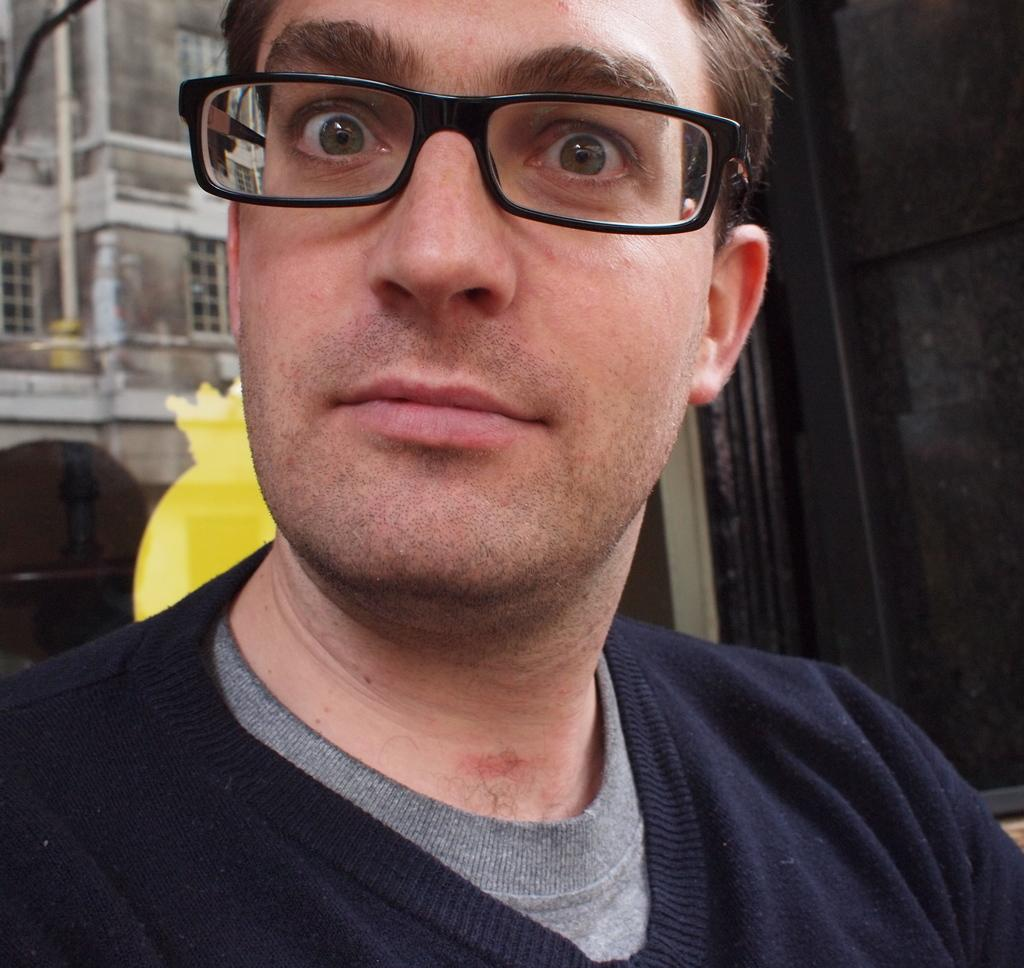Who is the main subject in the image? There is a man in the image. Where is the man positioned in the image? The man is in the front of the image. What is the man wearing? The man is wearing a black dress and specs. What can be seen in the background of the image? There is a building, windows, and a yellow color thing visible in the background. What type of battle is taking place in the image? There is no battle present in the image; it features a man in the front and a background with a building, windows, and a yellow color thing. Can you tell me where the church is located in the image? There is no church present in the image. 